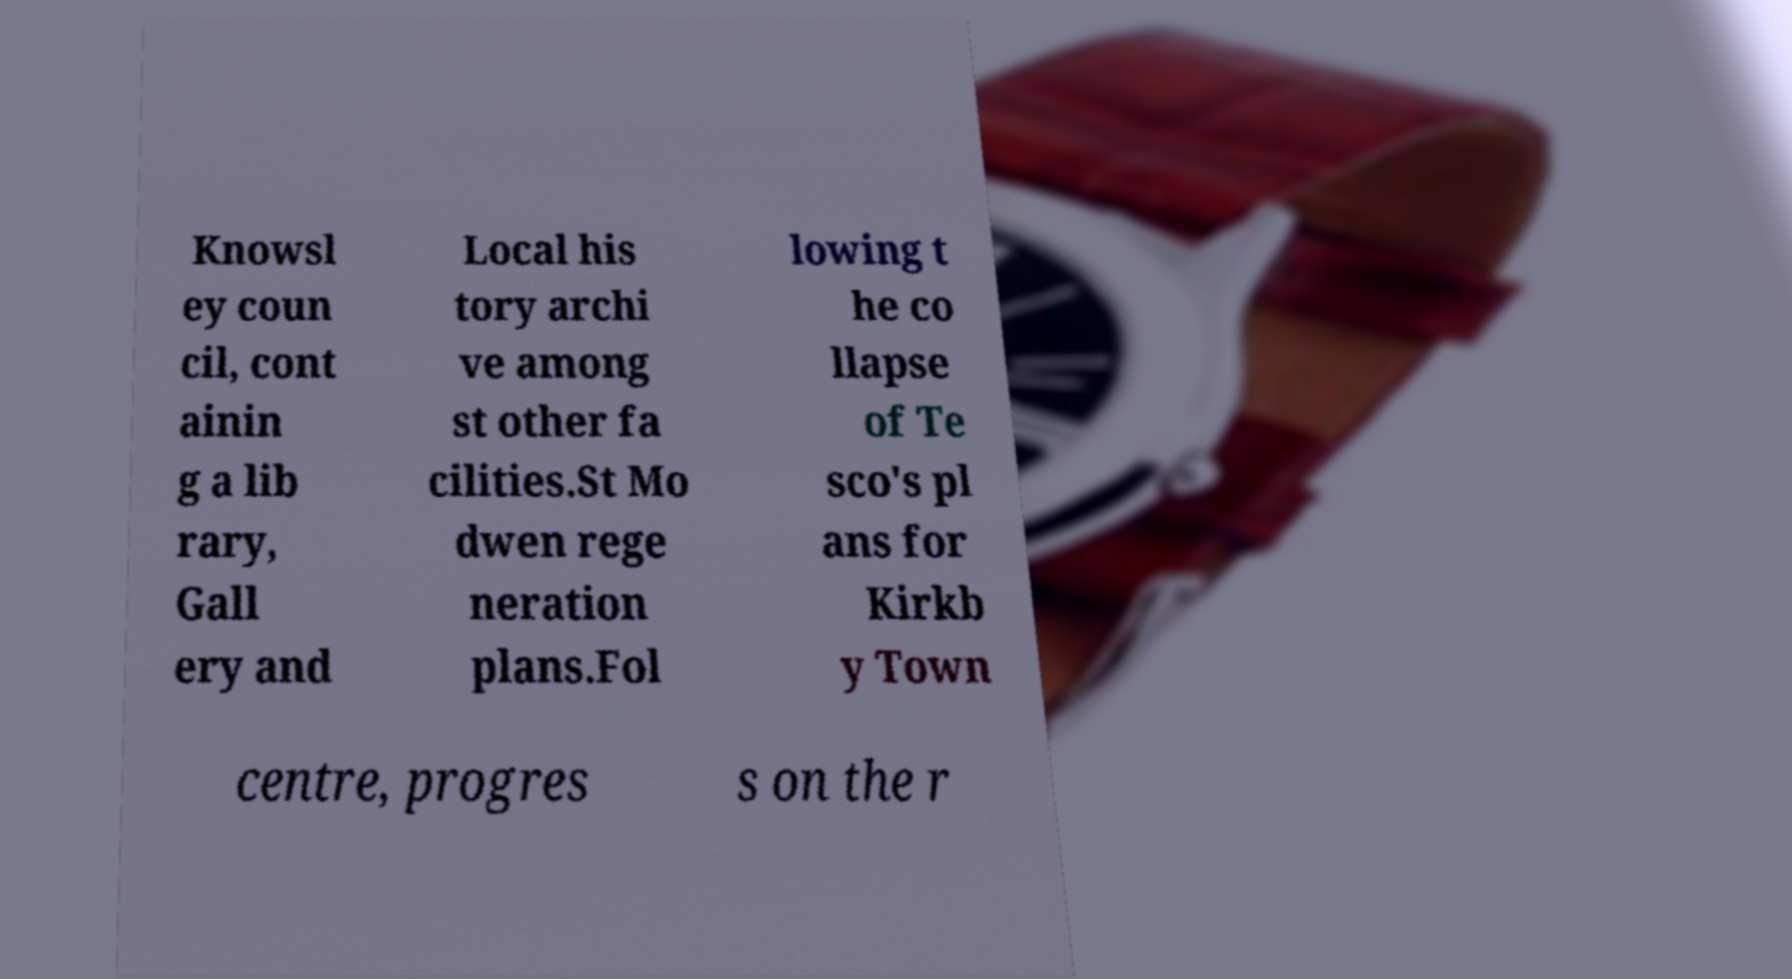Please read and relay the text visible in this image. What does it say? Knowsl ey coun cil, cont ainin g a lib rary, Gall ery and Local his tory archi ve among st other fa cilities.St Mo dwen rege neration plans.Fol lowing t he co llapse of Te sco's pl ans for Kirkb y Town centre, progres s on the r 